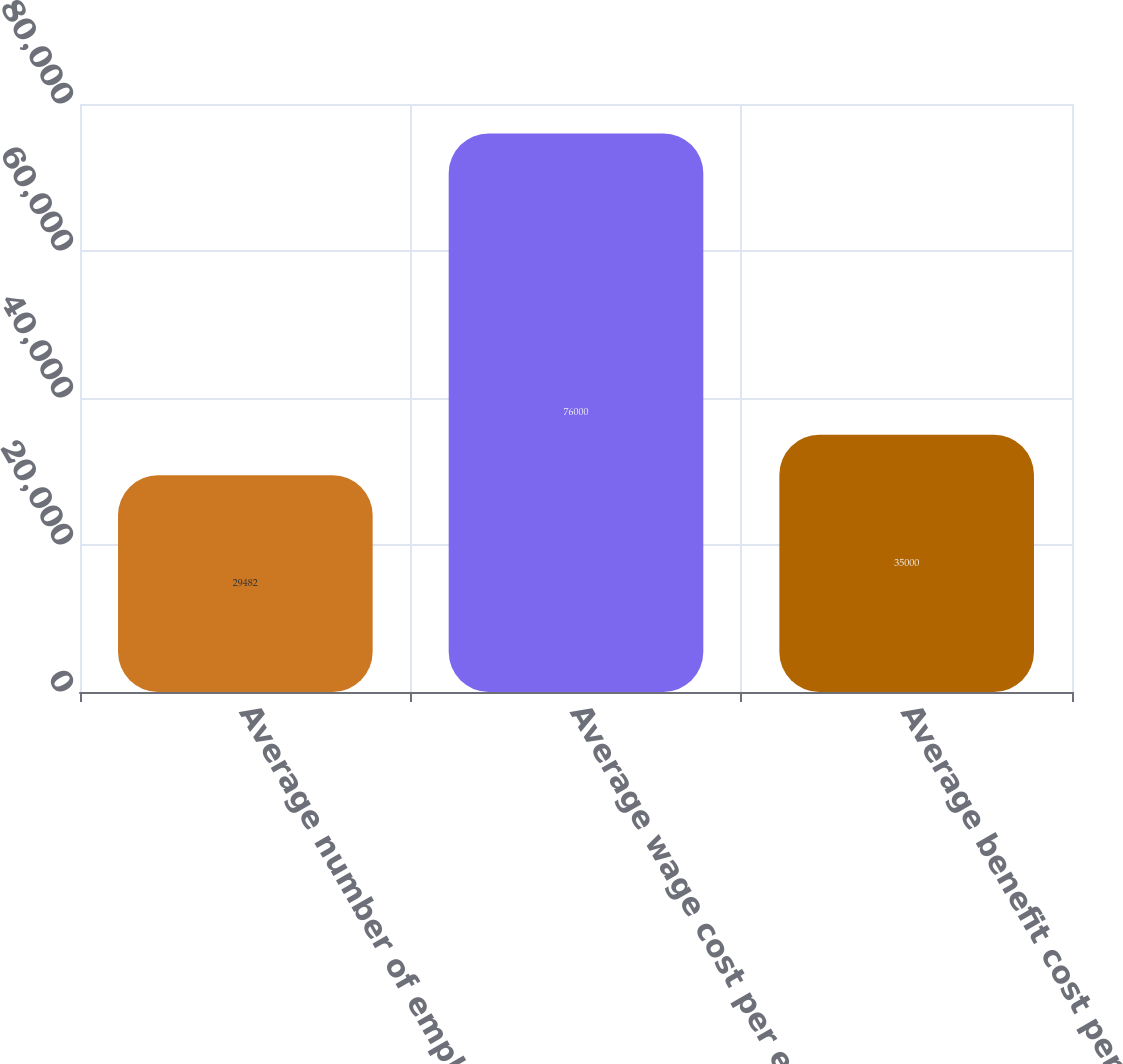<chart> <loc_0><loc_0><loc_500><loc_500><bar_chart><fcel>Average number of employees<fcel>Average wage cost per employee<fcel>Average benefit cost per<nl><fcel>29482<fcel>76000<fcel>35000<nl></chart> 